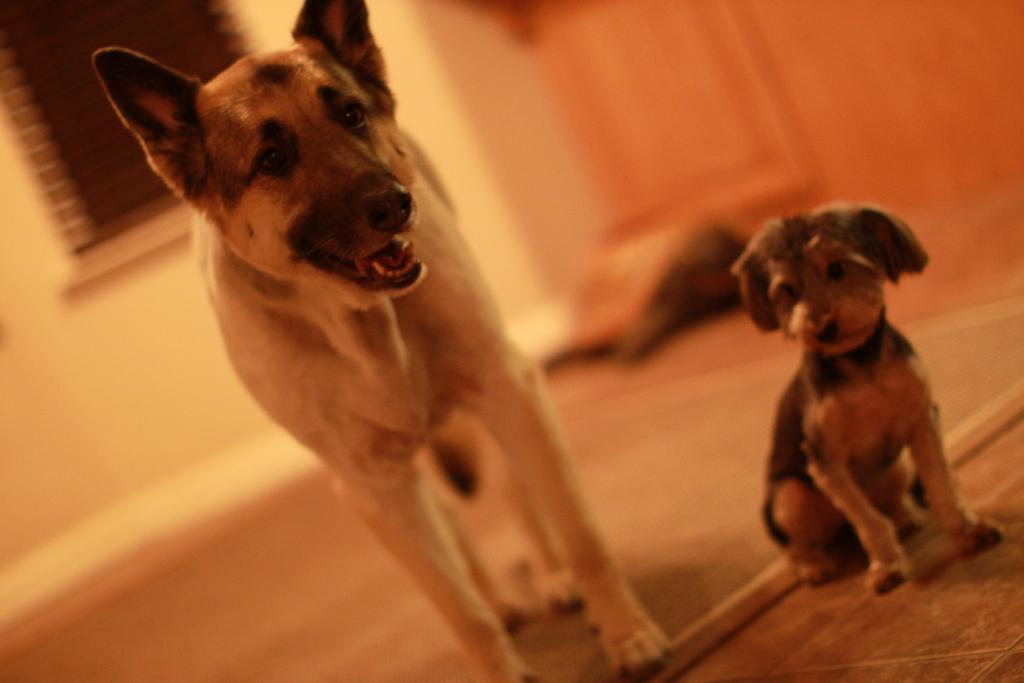Describe this image in one or two sentences. In this image I can see the brown colored floor and on it I can see two dogs which are brown and black in color. In the background I can see the wall, the window and few other blurry objects. 